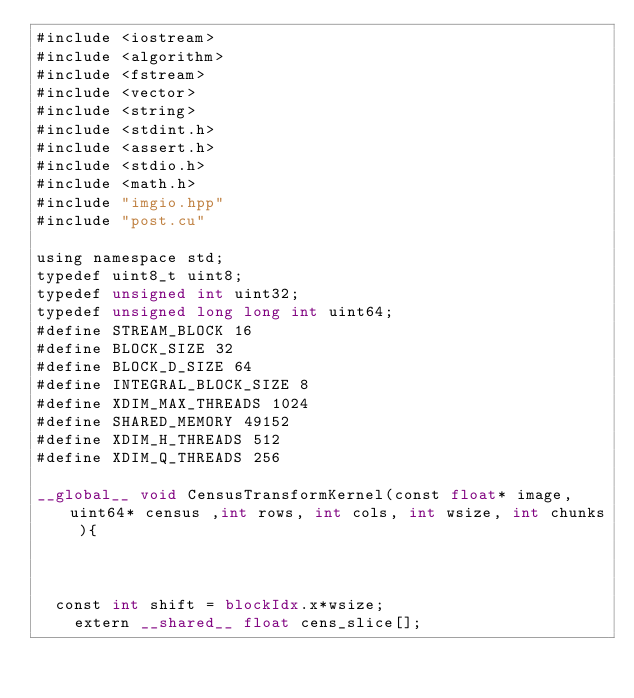Convert code to text. <code><loc_0><loc_0><loc_500><loc_500><_Cuda_>#include <iostream>
#include <algorithm>
#include <fstream>
#include <vector>
#include <string>
#include <stdint.h>
#include <assert.h>
#include <stdio.h>
#include <math.h> 
#include "imgio.hpp"
#include "post.cu"

using namespace std;
typedef uint8_t uint8;
typedef unsigned int uint32;
typedef unsigned long long int uint64;
#define STREAM_BLOCK 16
#define BLOCK_SIZE 32
#define BLOCK_D_SIZE 64
#define INTEGRAL_BLOCK_SIZE 8
#define XDIM_MAX_THREADS 1024
#define SHARED_MEMORY 49152
#define XDIM_H_THREADS 512
#define XDIM_Q_THREADS 256

__global__ void CensusTransformKernel(const float* image, uint64* census ,int rows, int cols, int wsize, int chunks ){



	const int shift = blockIdx.x*wsize;
    extern __shared__ float cens_slice[];</code> 